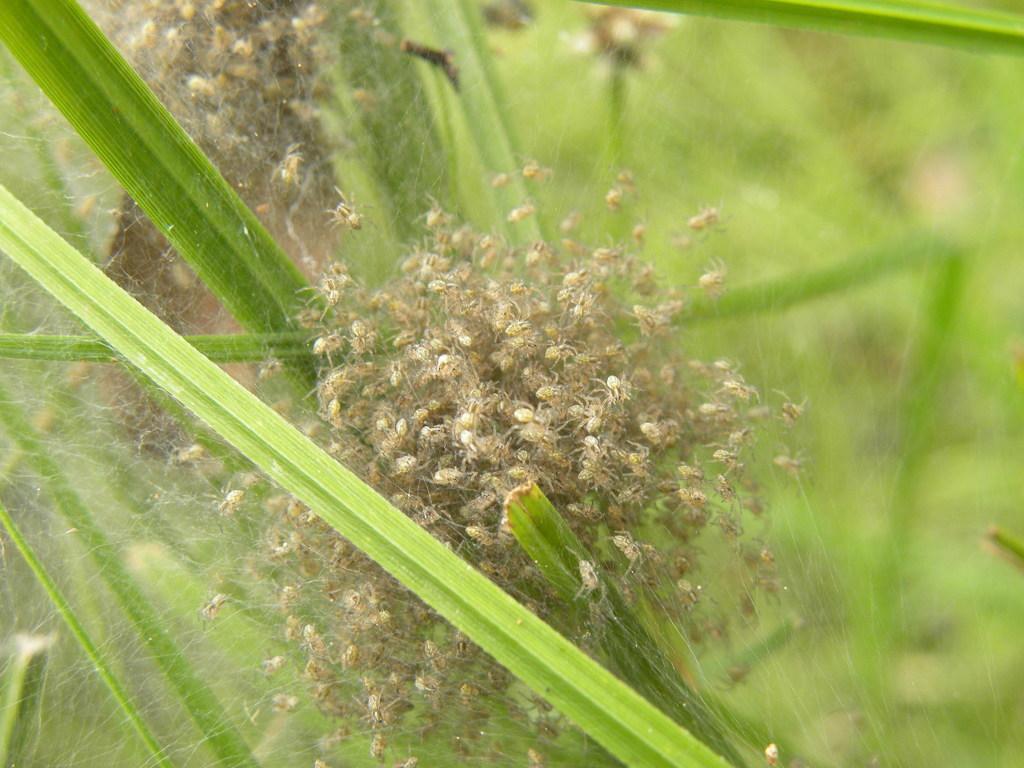What is present in the image that is related to spiders? There is a spider web in the image, and spiders are on the spider web. What can be inferred about the environment or setting of the image? The background of the image is green, which might suggest a natural or outdoor setting. What type of wine is being served in the image? There is no wine present in the image; it features a spider web and spiders. What material is the spider web made of in the image? The material of the spider web is not explicitly mentioned in the image, but spider webs are typically made of silk. 